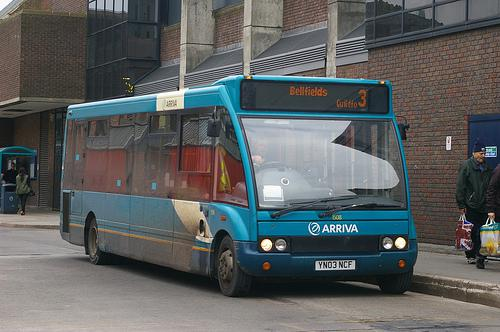Question: what is pictured?
Choices:
A. A bus.
B. A car.
C. A train.
D. A truck.
Answer with the letter. Answer: A Question: who is walking off camera?
Choices:
A. A man.
B. A woman.
C. A child.
D. The director.
Answer with the letter. Answer: A Question: what color is the bus?
Choices:
A. Red.
B. Yellow.
C. White.
D. Blue.
Answer with the letter. Answer: D Question: what is written on the bus led?
Choices:
A. Main Street.
B. Park Avenue.
C. Downtown.
D. Bellfields.
Answer with the letter. Answer: D 